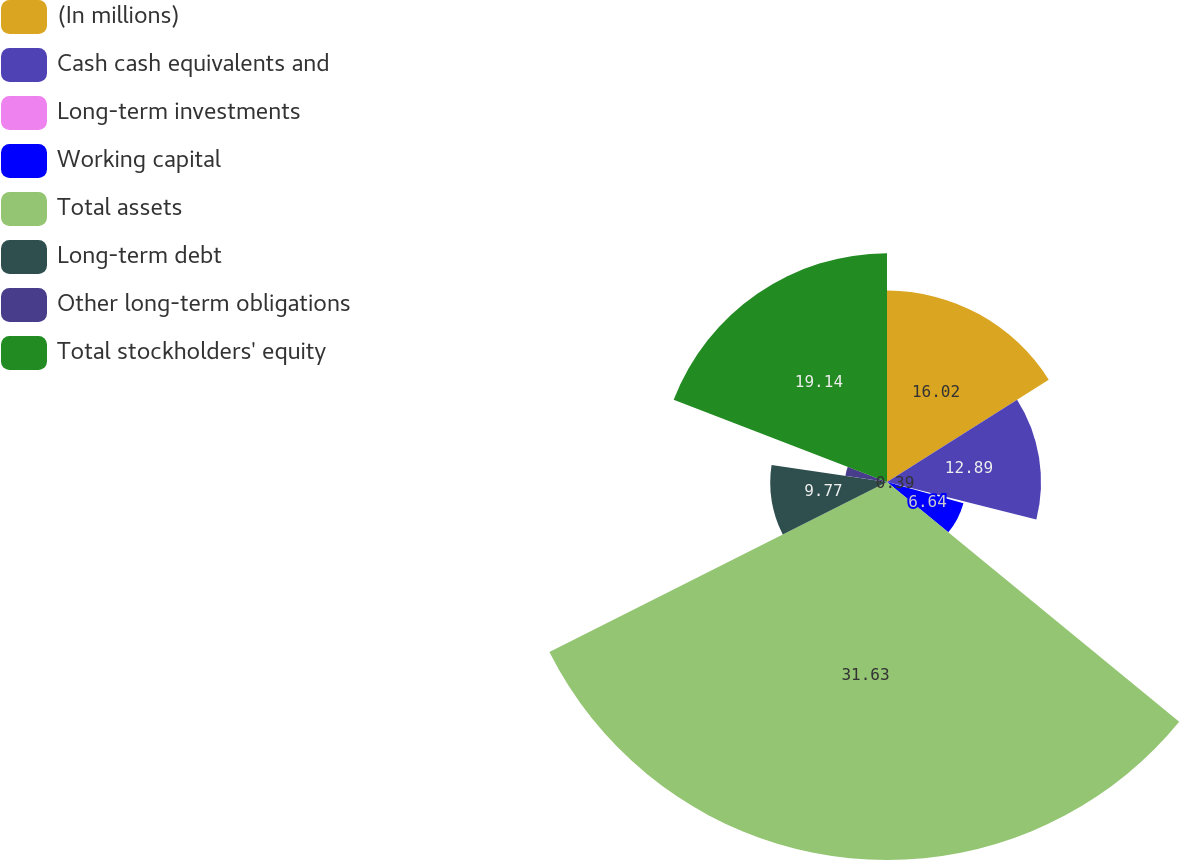Convert chart to OTSL. <chart><loc_0><loc_0><loc_500><loc_500><pie_chart><fcel>(In millions)<fcel>Cash cash equivalents and<fcel>Long-term investments<fcel>Working capital<fcel>Total assets<fcel>Long-term debt<fcel>Other long-term obligations<fcel>Total stockholders' equity<nl><fcel>16.02%<fcel>12.89%<fcel>0.39%<fcel>6.64%<fcel>31.64%<fcel>9.77%<fcel>3.52%<fcel>19.14%<nl></chart> 